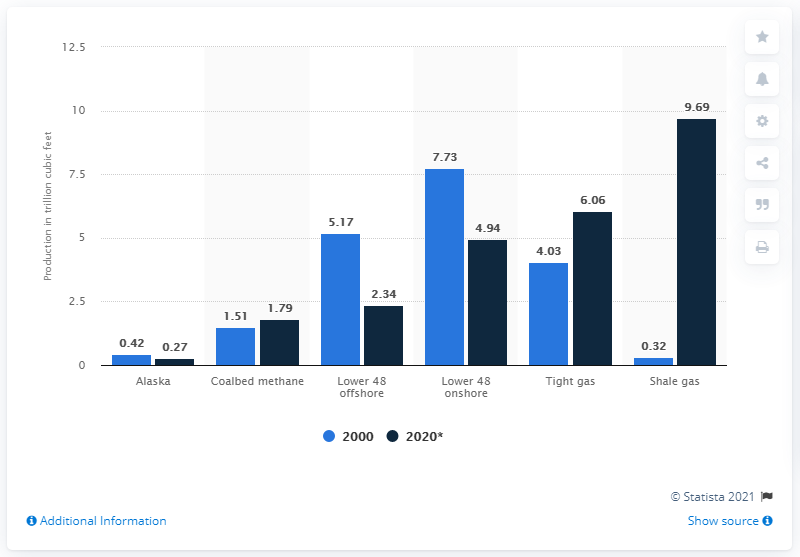Indicate a few pertinent items in this graphic. Alaska is expected to produce approximately 0.27 cubic feet of natural gas in 2020. In 2000, approximately 0.42 cubic feet of natural gas was produced in the state of Alaska. 